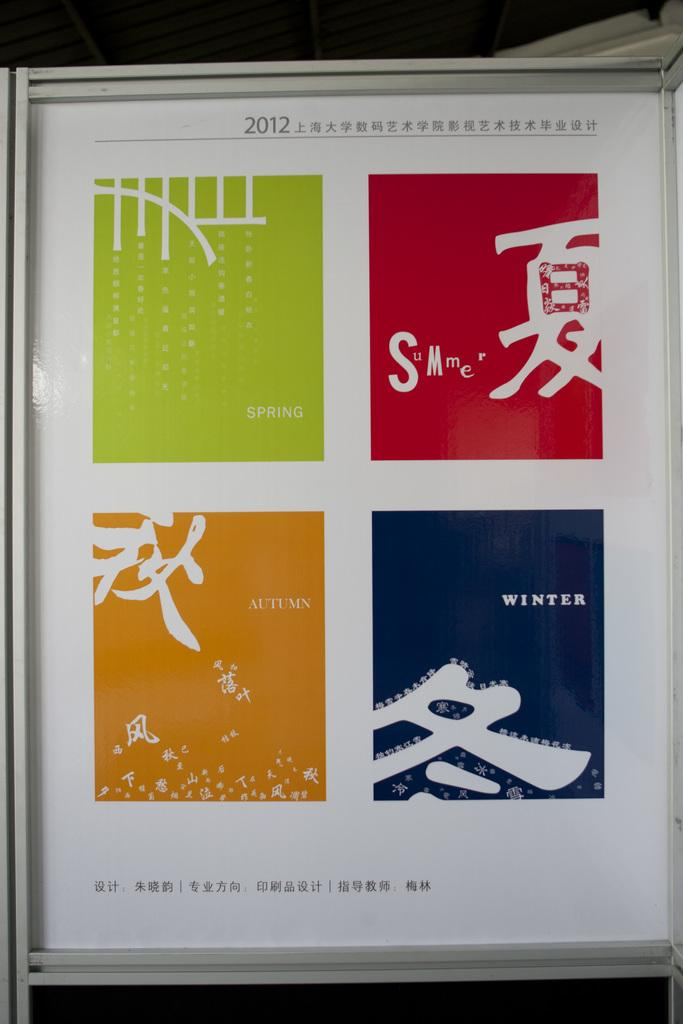<image>
Render a clear and concise summary of the photo. A bookcover with Spring, Summer, Autumn, and Winter in colored squares. 